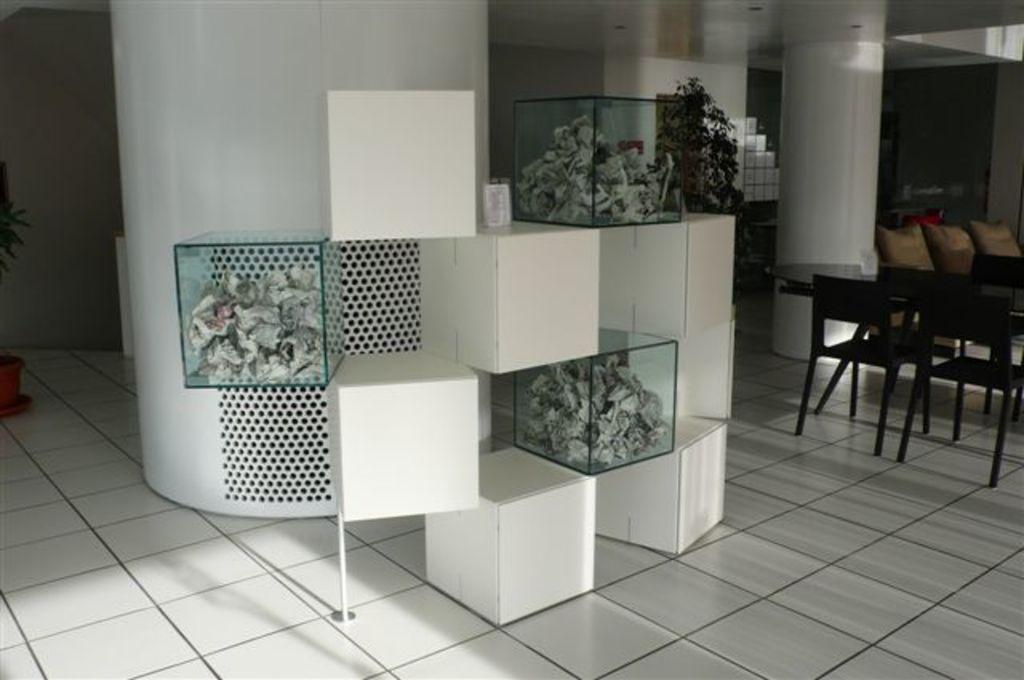What type of architectural feature can be seen in the image? There are pillars in the image. What type of objects are made of glass in the image? There are glass objects in the image. What part of the room is visible in the image? The floor is visible in the image. What type of furniture is present in the image? There are chairs and tables in the image. What type of vegetation is present in the image? There are plants in the image. What type of container is present in the image? There is a pot in the image. Are there any other objects present in the image besides the ones mentioned? Yes, there are other objects in the image. How many girls are helping the fireman put out the fire in the image? There is no fire or fireman present in the image. What type of muscle is visible on the person lifting the heavy object in the image? There is no person lifting a heavy object in the image. 